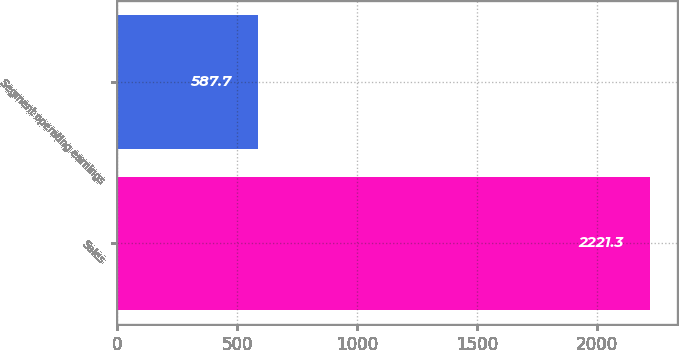Convert chart. <chart><loc_0><loc_0><loc_500><loc_500><bar_chart><fcel>Sales<fcel>Segment operating earnings<nl><fcel>2221.3<fcel>587.7<nl></chart> 